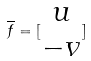Convert formula to latex. <formula><loc_0><loc_0><loc_500><loc_500>\overline { f } = [ \begin{matrix} u \\ - v \end{matrix} ]</formula> 